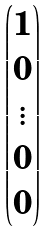Convert formula to latex. <formula><loc_0><loc_0><loc_500><loc_500>\begin{pmatrix} 1 \\ 0 \\ \vdots \\ 0 \\ 0 \end{pmatrix}</formula> 